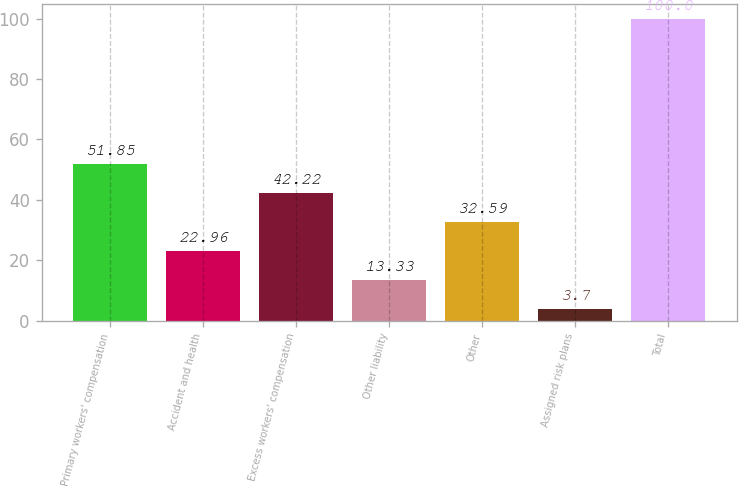<chart> <loc_0><loc_0><loc_500><loc_500><bar_chart><fcel>Primary workers' compensation<fcel>Accident and health<fcel>Excess workers' compensation<fcel>Other liability<fcel>Other<fcel>Assigned risk plans<fcel>Total<nl><fcel>51.85<fcel>22.96<fcel>42.22<fcel>13.33<fcel>32.59<fcel>3.7<fcel>100<nl></chart> 